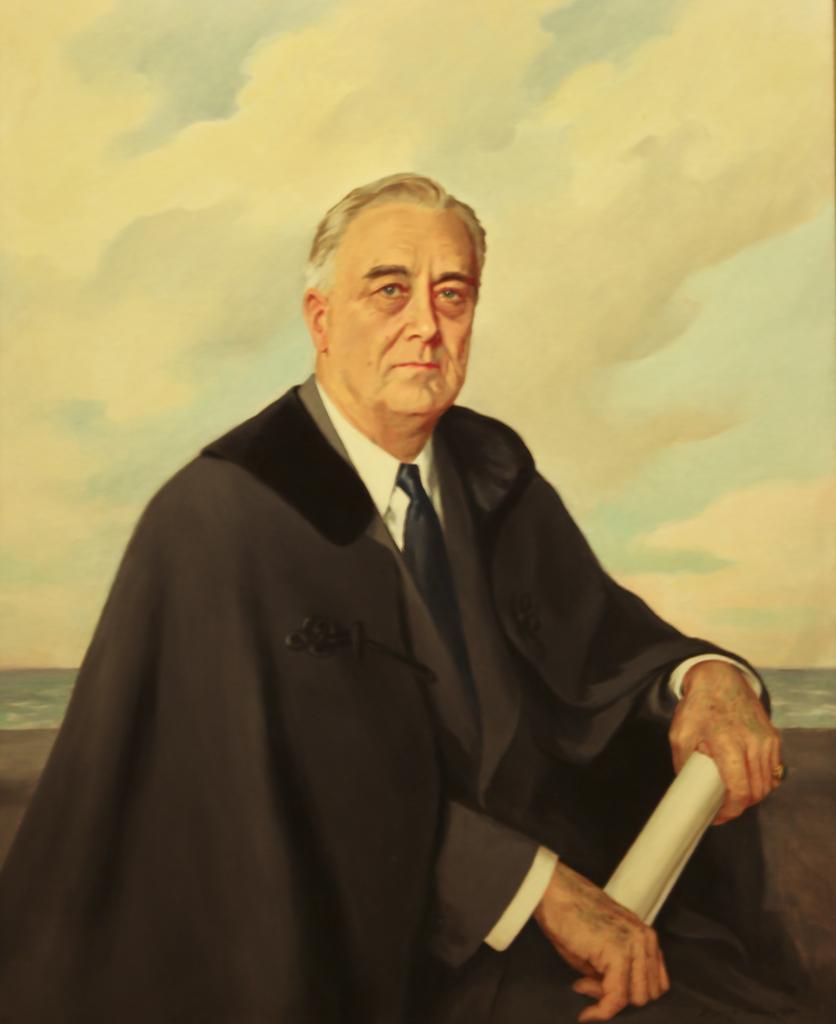Can you describe this image briefly? In this image we can see a painting of a person, and he is holding a paper. 